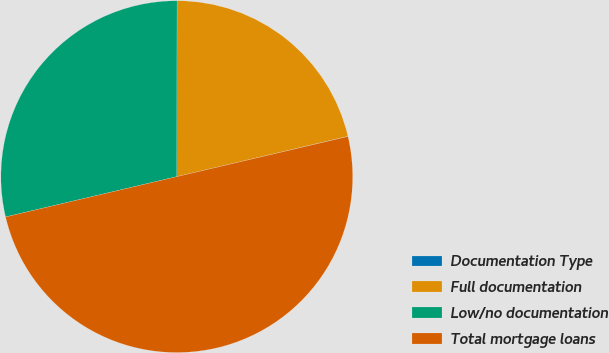Convert chart. <chart><loc_0><loc_0><loc_500><loc_500><pie_chart><fcel>Documentation Type<fcel>Full documentation<fcel>Low/no documentation<fcel>Total mortgage loans<nl><fcel>0.02%<fcel>21.29%<fcel>28.7%<fcel>49.99%<nl></chart> 